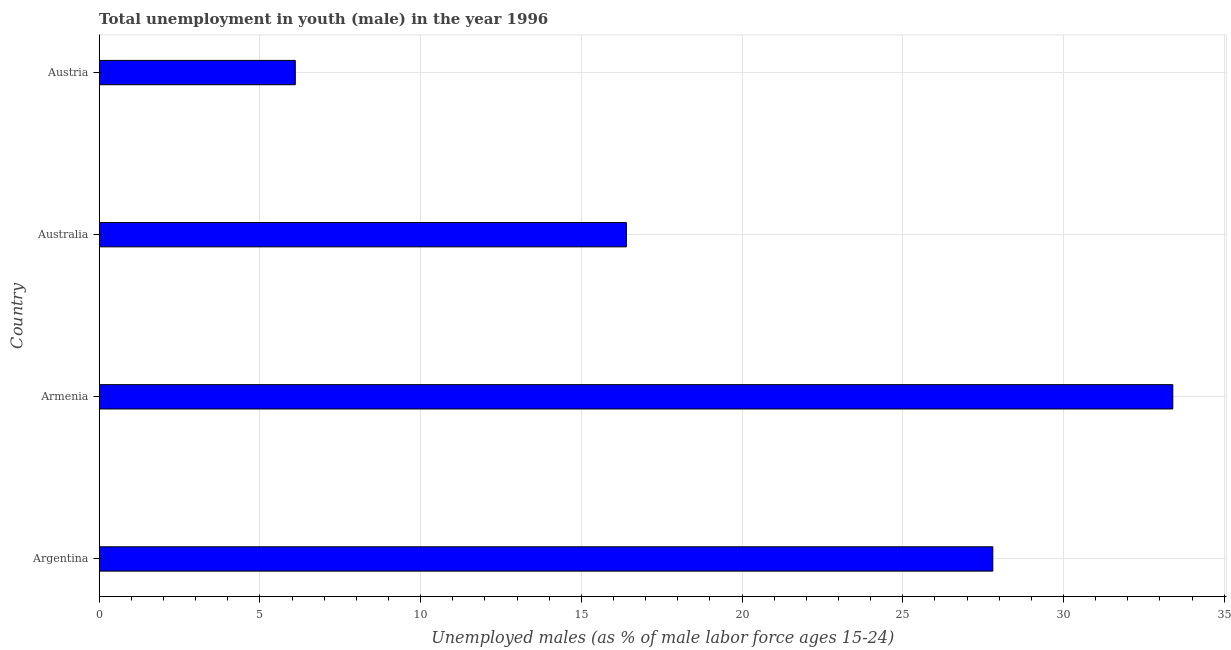What is the title of the graph?
Give a very brief answer. Total unemployment in youth (male) in the year 1996. What is the label or title of the X-axis?
Offer a very short reply. Unemployed males (as % of male labor force ages 15-24). What is the label or title of the Y-axis?
Your answer should be very brief. Country. What is the unemployed male youth population in Austria?
Offer a very short reply. 6.1. Across all countries, what is the maximum unemployed male youth population?
Your answer should be compact. 33.4. Across all countries, what is the minimum unemployed male youth population?
Make the answer very short. 6.1. In which country was the unemployed male youth population maximum?
Offer a very short reply. Armenia. In which country was the unemployed male youth population minimum?
Offer a terse response. Austria. What is the sum of the unemployed male youth population?
Offer a very short reply. 83.7. What is the difference between the unemployed male youth population in Argentina and Austria?
Keep it short and to the point. 21.7. What is the average unemployed male youth population per country?
Make the answer very short. 20.93. What is the median unemployed male youth population?
Keep it short and to the point. 22.1. What is the ratio of the unemployed male youth population in Argentina to that in Austria?
Offer a very short reply. 4.56. Is the unemployed male youth population in Armenia less than that in Austria?
Keep it short and to the point. No. Is the sum of the unemployed male youth population in Australia and Austria greater than the maximum unemployed male youth population across all countries?
Make the answer very short. No. What is the difference between the highest and the lowest unemployed male youth population?
Ensure brevity in your answer.  27.3. How many bars are there?
Your response must be concise. 4. Are all the bars in the graph horizontal?
Offer a terse response. Yes. How many countries are there in the graph?
Make the answer very short. 4. What is the difference between two consecutive major ticks on the X-axis?
Ensure brevity in your answer.  5. Are the values on the major ticks of X-axis written in scientific E-notation?
Make the answer very short. No. What is the Unemployed males (as % of male labor force ages 15-24) in Argentina?
Keep it short and to the point. 27.8. What is the Unemployed males (as % of male labor force ages 15-24) in Armenia?
Offer a very short reply. 33.4. What is the Unemployed males (as % of male labor force ages 15-24) of Australia?
Provide a short and direct response. 16.4. What is the Unemployed males (as % of male labor force ages 15-24) in Austria?
Ensure brevity in your answer.  6.1. What is the difference between the Unemployed males (as % of male labor force ages 15-24) in Argentina and Armenia?
Provide a succinct answer. -5.6. What is the difference between the Unemployed males (as % of male labor force ages 15-24) in Argentina and Australia?
Your response must be concise. 11.4. What is the difference between the Unemployed males (as % of male labor force ages 15-24) in Argentina and Austria?
Offer a very short reply. 21.7. What is the difference between the Unemployed males (as % of male labor force ages 15-24) in Armenia and Australia?
Ensure brevity in your answer.  17. What is the difference between the Unemployed males (as % of male labor force ages 15-24) in Armenia and Austria?
Your response must be concise. 27.3. What is the difference between the Unemployed males (as % of male labor force ages 15-24) in Australia and Austria?
Provide a succinct answer. 10.3. What is the ratio of the Unemployed males (as % of male labor force ages 15-24) in Argentina to that in Armenia?
Your response must be concise. 0.83. What is the ratio of the Unemployed males (as % of male labor force ages 15-24) in Argentina to that in Australia?
Provide a succinct answer. 1.7. What is the ratio of the Unemployed males (as % of male labor force ages 15-24) in Argentina to that in Austria?
Offer a very short reply. 4.56. What is the ratio of the Unemployed males (as % of male labor force ages 15-24) in Armenia to that in Australia?
Your answer should be compact. 2.04. What is the ratio of the Unemployed males (as % of male labor force ages 15-24) in Armenia to that in Austria?
Keep it short and to the point. 5.47. What is the ratio of the Unemployed males (as % of male labor force ages 15-24) in Australia to that in Austria?
Give a very brief answer. 2.69. 